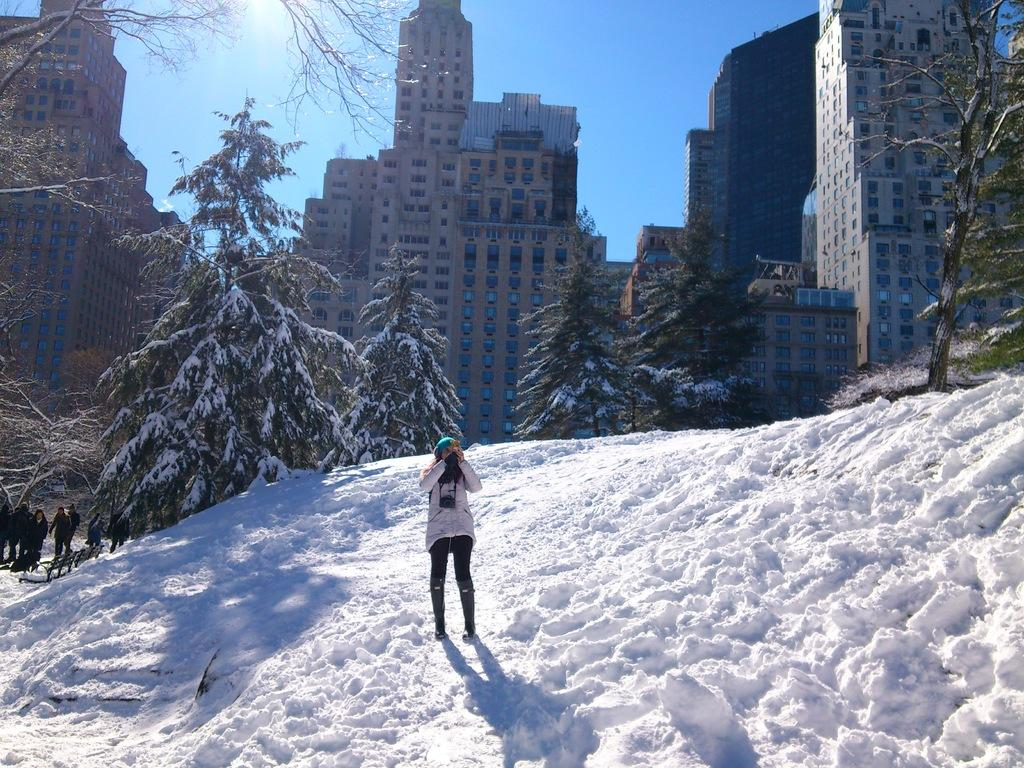What is happening in the foreground of the picture? There is a woman standing in the snow in the foreground of the picture. What can be seen in the center of the picture? There are trees and people in the center of the picture. What is visible in the background of the picture? There are buildings in the background of the picture. How would you describe the weather in the image? The sky is sunny, suggesting a clear and bright day. What type of punishment is being administered to the woman in the snow? There is no indication of punishment in the image; the woman is simply standing in the snow. Where is the library located in the image? There is no library present in the image. Can you see a ship in the background of the image? No, there are no ships visible in the image; only buildings are present in the background. 